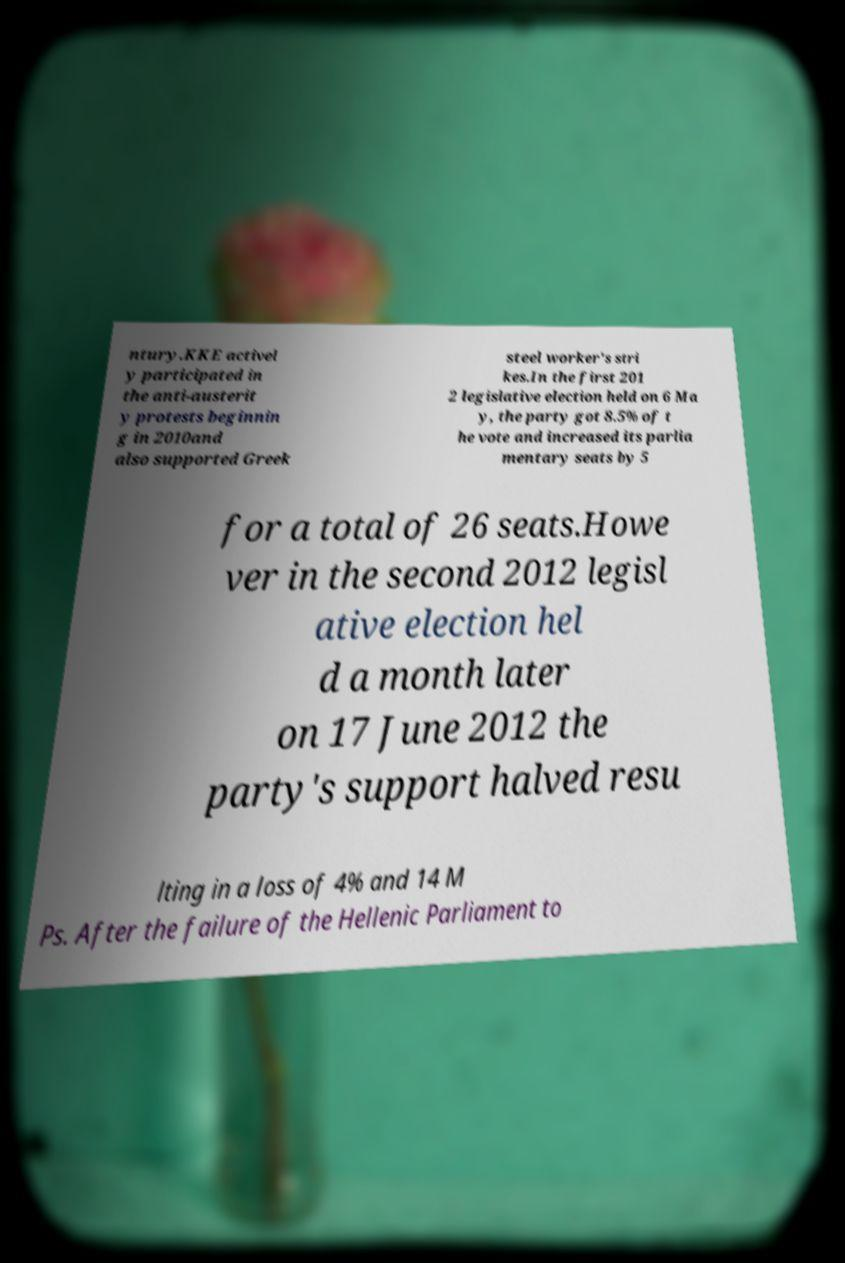What messages or text are displayed in this image? I need them in a readable, typed format. ntury.KKE activel y participated in the anti-austerit y protests beginnin g in 2010and also supported Greek steel worker's stri kes.In the first 201 2 legislative election held on 6 Ma y, the party got 8.5% of t he vote and increased its parlia mentary seats by 5 for a total of 26 seats.Howe ver in the second 2012 legisl ative election hel d a month later on 17 June 2012 the party's support halved resu lting in a loss of 4% and 14 M Ps. After the failure of the Hellenic Parliament to 